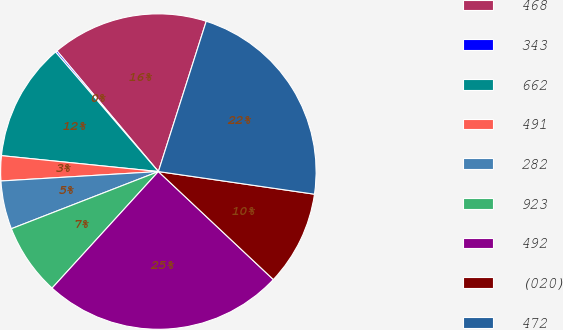Convert chart to OTSL. <chart><loc_0><loc_0><loc_500><loc_500><pie_chart><fcel>468<fcel>343<fcel>662<fcel>491<fcel>282<fcel>923<fcel>492<fcel>(020)<fcel>472<nl><fcel>16.03%<fcel>0.18%<fcel>12.09%<fcel>2.56%<fcel>4.95%<fcel>7.33%<fcel>24.77%<fcel>9.71%<fcel>22.39%<nl></chart> 